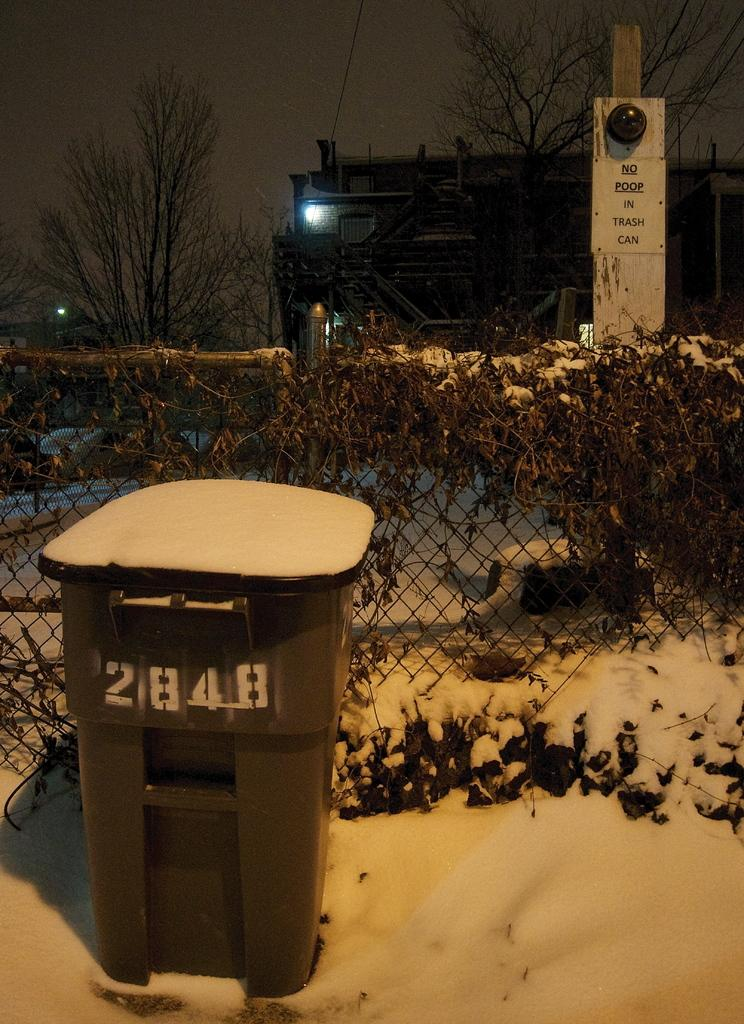<image>
Provide a brief description of the given image. A trash can is sitting in the snow with a # 2848. 